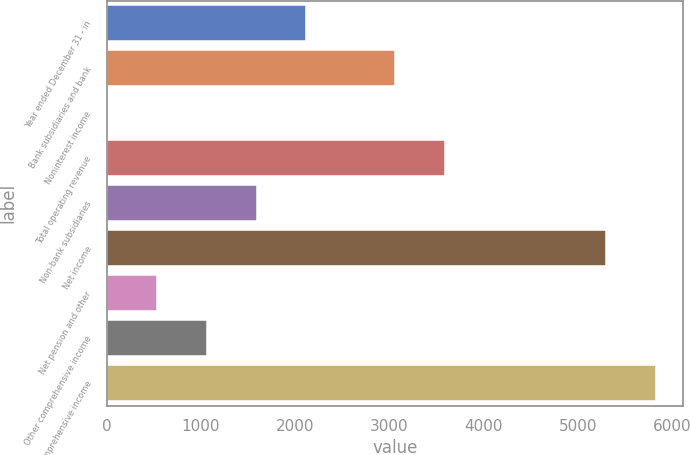<chart> <loc_0><loc_0><loc_500><loc_500><bar_chart><fcel>Year ended December 31 - in<fcel>Bank subsidiaries and bank<fcel>Noninterest income<fcel>Total operating revenue<fcel>Non-bank subsidiaries<fcel>Net income<fcel>Net pension and other<fcel>Other comprehensive income<fcel>Comprehensive income<nl><fcel>2121.4<fcel>3057<fcel>1<fcel>3587.1<fcel>1591.3<fcel>5301<fcel>531.1<fcel>1061.2<fcel>5831.1<nl></chart> 